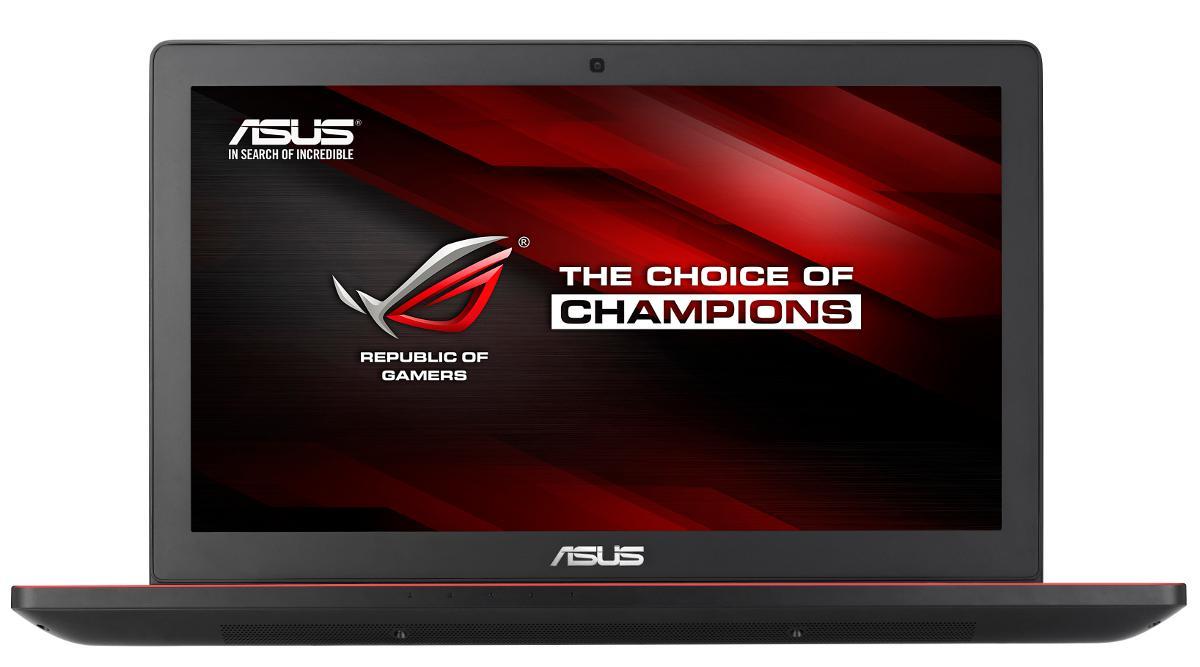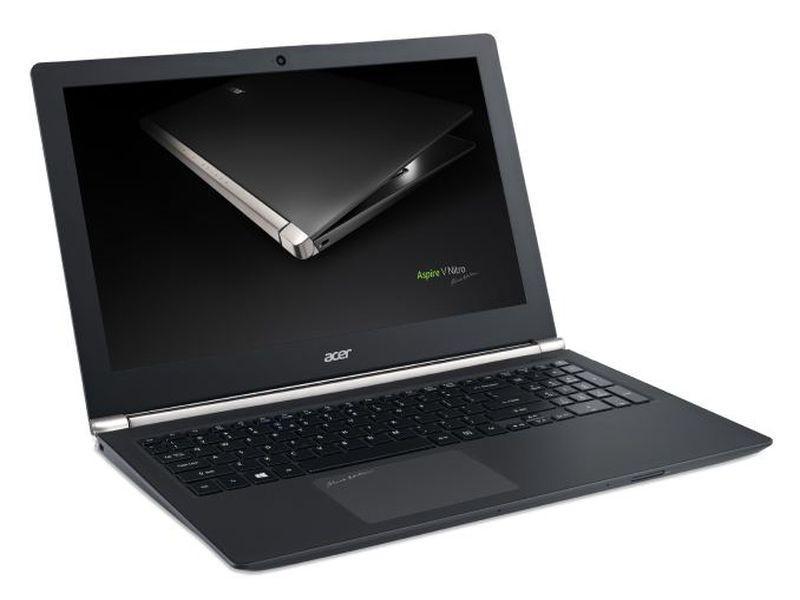The first image is the image on the left, the second image is the image on the right. Analyze the images presented: Is the assertion "there are two laptops fully open in the image pair" valid? Answer yes or no. Yes. 